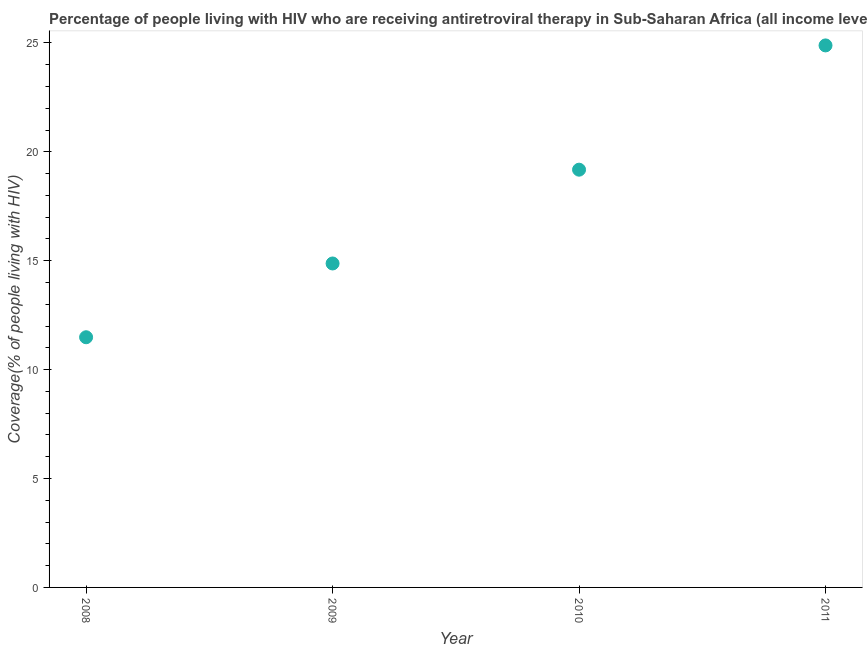What is the antiretroviral therapy coverage in 2009?
Offer a terse response. 14.88. Across all years, what is the maximum antiretroviral therapy coverage?
Ensure brevity in your answer.  24.89. Across all years, what is the minimum antiretroviral therapy coverage?
Offer a very short reply. 11.49. In which year was the antiretroviral therapy coverage minimum?
Keep it short and to the point. 2008. What is the sum of the antiretroviral therapy coverage?
Your answer should be very brief. 70.44. What is the difference between the antiretroviral therapy coverage in 2008 and 2009?
Your answer should be compact. -3.39. What is the average antiretroviral therapy coverage per year?
Give a very brief answer. 17.61. What is the median antiretroviral therapy coverage?
Your answer should be very brief. 17.03. Do a majority of the years between 2009 and 2010 (inclusive) have antiretroviral therapy coverage greater than 15 %?
Keep it short and to the point. No. What is the ratio of the antiretroviral therapy coverage in 2009 to that in 2011?
Your response must be concise. 0.6. Is the antiretroviral therapy coverage in 2010 less than that in 2011?
Your response must be concise. Yes. What is the difference between the highest and the second highest antiretroviral therapy coverage?
Ensure brevity in your answer.  5.71. Is the sum of the antiretroviral therapy coverage in 2008 and 2009 greater than the maximum antiretroviral therapy coverage across all years?
Your answer should be very brief. Yes. What is the difference between the highest and the lowest antiretroviral therapy coverage?
Your answer should be compact. 13.4. Does the antiretroviral therapy coverage monotonically increase over the years?
Keep it short and to the point. Yes. How many dotlines are there?
Your answer should be very brief. 1. Does the graph contain any zero values?
Provide a succinct answer. No. Does the graph contain grids?
Offer a terse response. No. What is the title of the graph?
Give a very brief answer. Percentage of people living with HIV who are receiving antiretroviral therapy in Sub-Saharan Africa (all income levels). What is the label or title of the Y-axis?
Offer a terse response. Coverage(% of people living with HIV). What is the Coverage(% of people living with HIV) in 2008?
Provide a succinct answer. 11.49. What is the Coverage(% of people living with HIV) in 2009?
Provide a succinct answer. 14.88. What is the Coverage(% of people living with HIV) in 2010?
Offer a very short reply. 19.18. What is the Coverage(% of people living with HIV) in 2011?
Give a very brief answer. 24.89. What is the difference between the Coverage(% of people living with HIV) in 2008 and 2009?
Your answer should be very brief. -3.39. What is the difference between the Coverage(% of people living with HIV) in 2008 and 2010?
Your answer should be compact. -7.69. What is the difference between the Coverage(% of people living with HIV) in 2008 and 2011?
Ensure brevity in your answer.  -13.4. What is the difference between the Coverage(% of people living with HIV) in 2009 and 2010?
Provide a succinct answer. -4.31. What is the difference between the Coverage(% of people living with HIV) in 2009 and 2011?
Provide a succinct answer. -10.01. What is the difference between the Coverage(% of people living with HIV) in 2010 and 2011?
Make the answer very short. -5.71. What is the ratio of the Coverage(% of people living with HIV) in 2008 to that in 2009?
Offer a terse response. 0.77. What is the ratio of the Coverage(% of people living with HIV) in 2008 to that in 2010?
Your answer should be very brief. 0.6. What is the ratio of the Coverage(% of people living with HIV) in 2008 to that in 2011?
Your response must be concise. 0.46. What is the ratio of the Coverage(% of people living with HIV) in 2009 to that in 2010?
Provide a short and direct response. 0.78. What is the ratio of the Coverage(% of people living with HIV) in 2009 to that in 2011?
Your answer should be very brief. 0.6. What is the ratio of the Coverage(% of people living with HIV) in 2010 to that in 2011?
Offer a terse response. 0.77. 